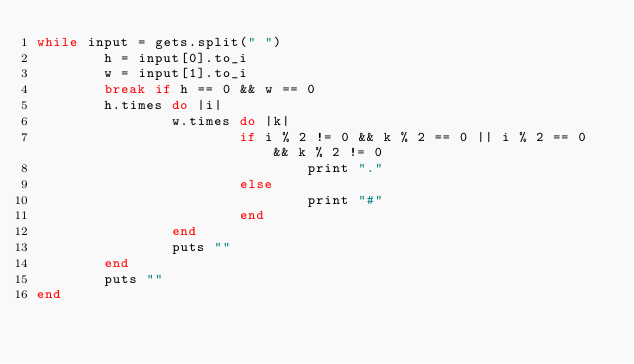Convert code to text. <code><loc_0><loc_0><loc_500><loc_500><_Ruby_>while input = gets.split(" ")
        h = input[0].to_i
        w = input[1].to_i
        break if h == 0 && w == 0
        h.times do |i|
                w.times do |k|
                        if i % 2 != 0 && k % 2 == 0 || i % 2 == 0 && k % 2 != 0
                                print "."
                        else
                                print "#"
                        end
                end
                puts ""
        end
        puts ""
end</code> 